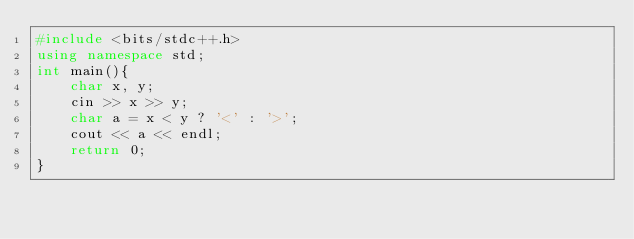<code> <loc_0><loc_0><loc_500><loc_500><_C++_>#include <bits/stdc++.h>
using namespace std;
int main(){
	char x, y;
	cin >> x >> y;
	char a = x < y ? '<' : '>';
	cout << a << endl;
	return 0;
}</code> 